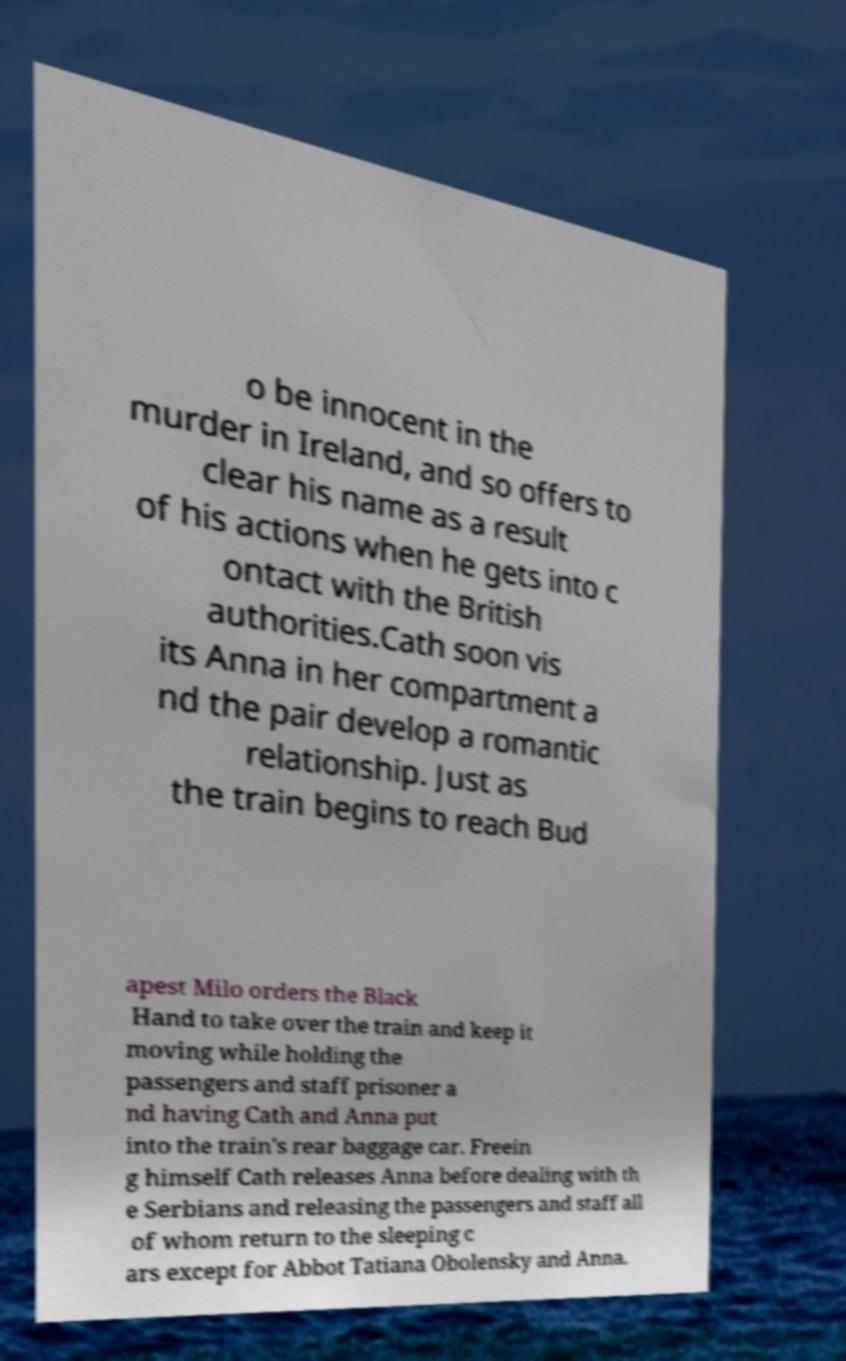Please read and relay the text visible in this image. What does it say? o be innocent in the murder in Ireland, and so offers to clear his name as a result of his actions when he gets into c ontact with the British authorities.Cath soon vis its Anna in her compartment a nd the pair develop a romantic relationship. Just as the train begins to reach Bud apest Milo orders the Black Hand to take over the train and keep it moving while holding the passengers and staff prisoner a nd having Cath and Anna put into the train's rear baggage car. Freein g himself Cath releases Anna before dealing with th e Serbians and releasing the passengers and staff all of whom return to the sleeping c ars except for Abbot Tatiana Obolensky and Anna. 